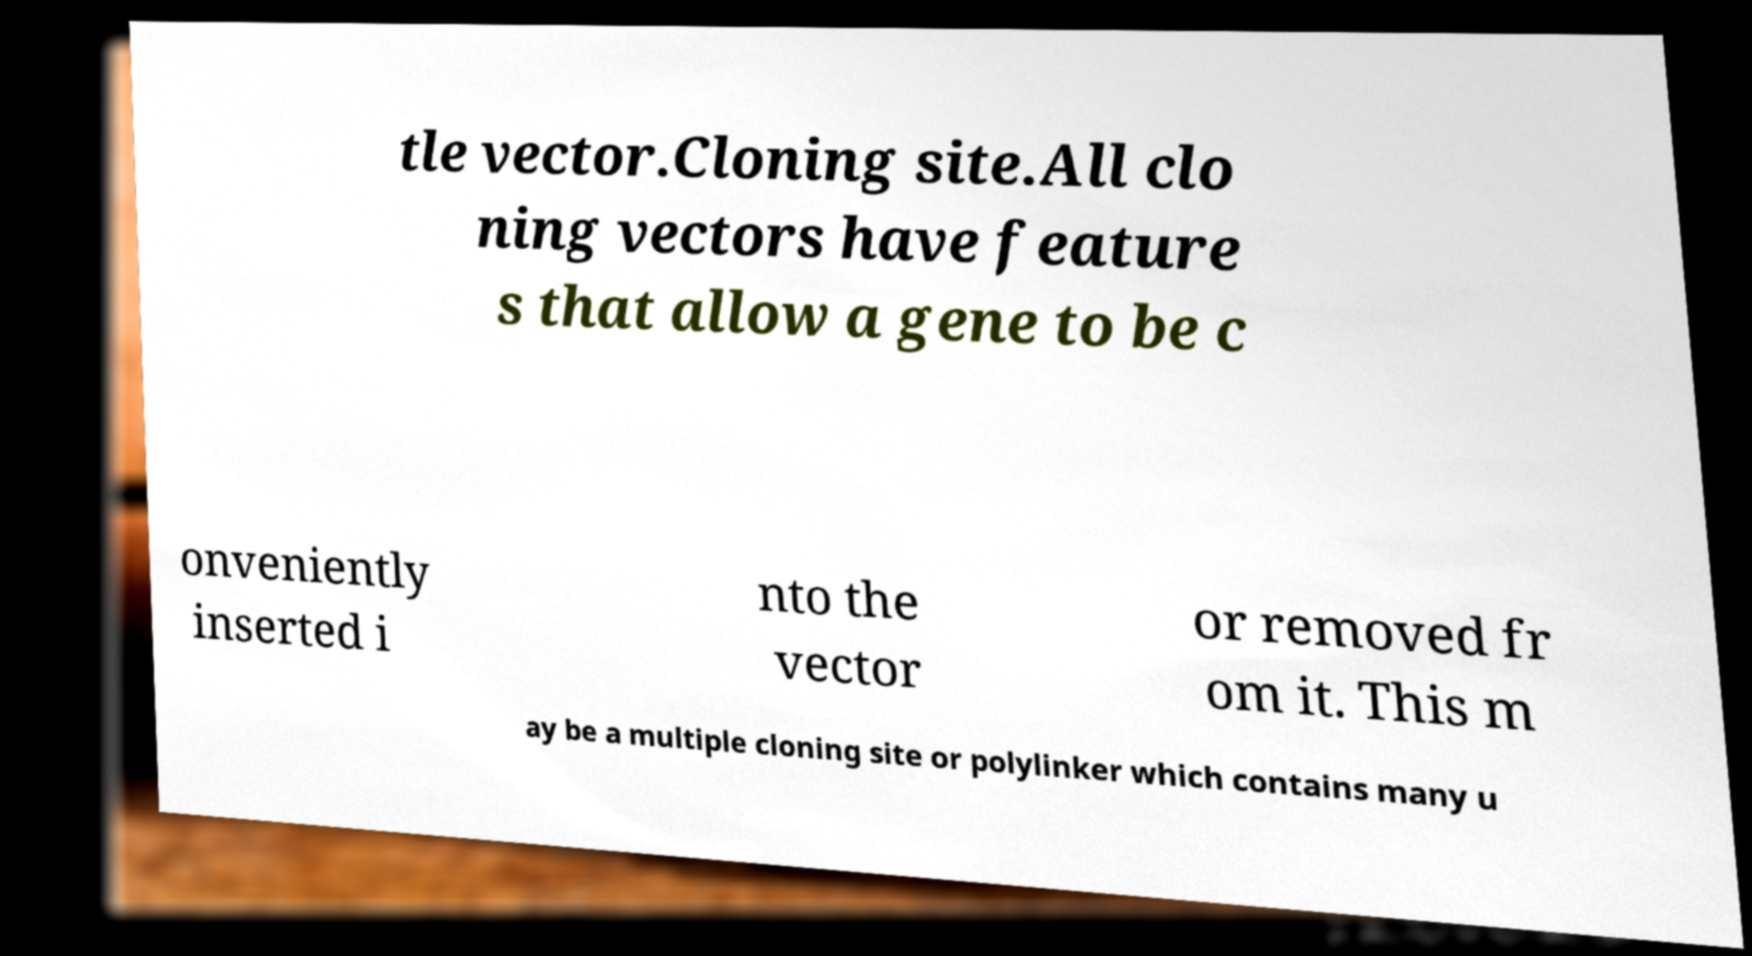Could you extract and type out the text from this image? tle vector.Cloning site.All clo ning vectors have feature s that allow a gene to be c onveniently inserted i nto the vector or removed fr om it. This m ay be a multiple cloning site or polylinker which contains many u 